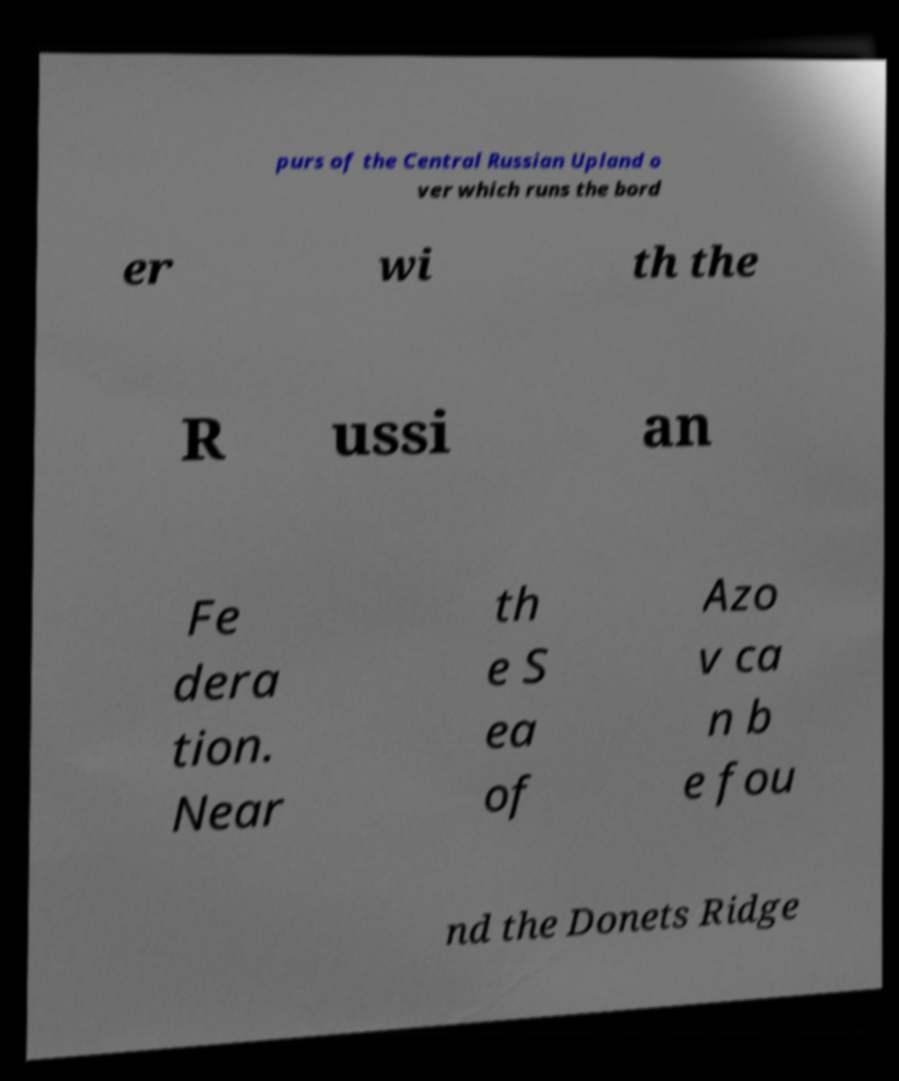Please identify and transcribe the text found in this image. purs of the Central Russian Upland o ver which runs the bord er wi th the R ussi an Fe dera tion. Near th e S ea of Azo v ca n b e fou nd the Donets Ridge 